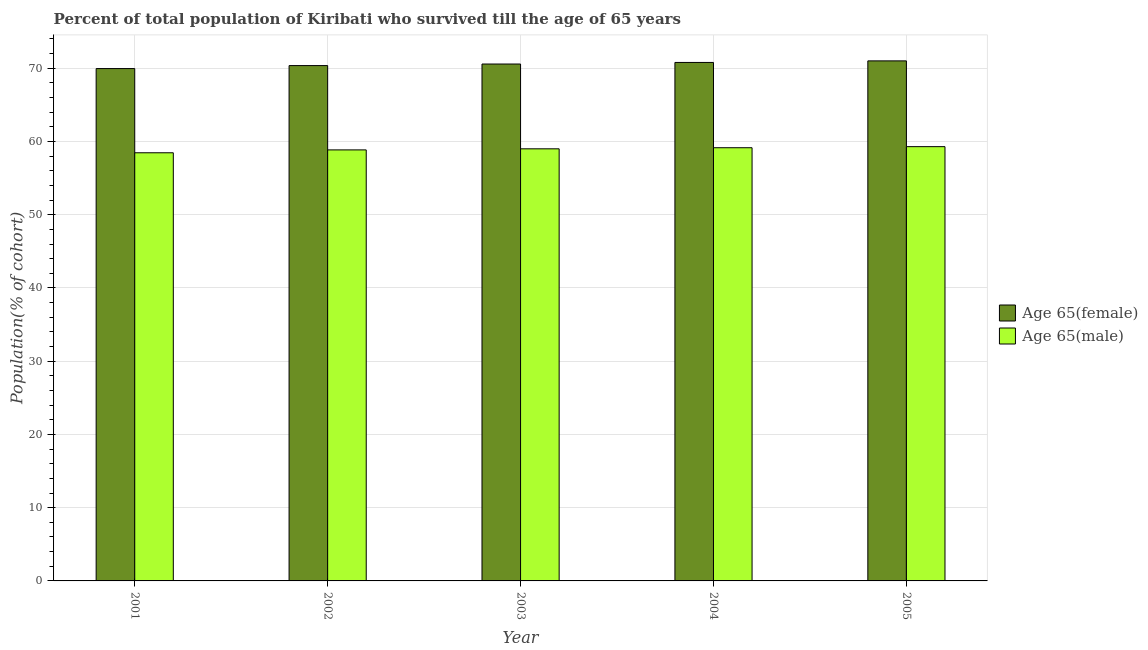Are the number of bars per tick equal to the number of legend labels?
Keep it short and to the point. Yes. Are the number of bars on each tick of the X-axis equal?
Offer a terse response. Yes. How many bars are there on the 1st tick from the right?
Your response must be concise. 2. What is the label of the 1st group of bars from the left?
Ensure brevity in your answer.  2001. In how many cases, is the number of bars for a given year not equal to the number of legend labels?
Offer a very short reply. 0. What is the percentage of male population who survived till age of 65 in 2001?
Your response must be concise. 58.46. Across all years, what is the maximum percentage of male population who survived till age of 65?
Your answer should be very brief. 59.3. Across all years, what is the minimum percentage of female population who survived till age of 65?
Offer a very short reply. 69.96. What is the total percentage of male population who survived till age of 65 in the graph?
Provide a short and direct response. 294.76. What is the difference between the percentage of female population who survived till age of 65 in 2004 and that in 2005?
Give a very brief answer. -0.21. What is the difference between the percentage of male population who survived till age of 65 in 2001 and the percentage of female population who survived till age of 65 in 2004?
Give a very brief answer. -0.69. What is the average percentage of female population who survived till age of 65 per year?
Provide a short and direct response. 70.54. In how many years, is the percentage of male population who survived till age of 65 greater than 42 %?
Keep it short and to the point. 5. What is the ratio of the percentage of male population who survived till age of 65 in 2002 to that in 2004?
Your answer should be very brief. 1. What is the difference between the highest and the second highest percentage of female population who survived till age of 65?
Keep it short and to the point. 0.21. What is the difference between the highest and the lowest percentage of male population who survived till age of 65?
Ensure brevity in your answer.  0.84. What does the 1st bar from the left in 2003 represents?
Your response must be concise. Age 65(female). What does the 1st bar from the right in 2001 represents?
Offer a terse response. Age 65(male). Are all the bars in the graph horizontal?
Your answer should be very brief. No. How many years are there in the graph?
Your response must be concise. 5. What is the difference between two consecutive major ticks on the Y-axis?
Your response must be concise. 10. Does the graph contain grids?
Your answer should be very brief. Yes. Where does the legend appear in the graph?
Make the answer very short. Center right. How are the legend labels stacked?
Provide a succinct answer. Vertical. What is the title of the graph?
Your answer should be very brief. Percent of total population of Kiribati who survived till the age of 65 years. What is the label or title of the Y-axis?
Ensure brevity in your answer.  Population(% of cohort). What is the Population(% of cohort) in Age 65(female) in 2001?
Provide a succinct answer. 69.96. What is the Population(% of cohort) in Age 65(male) in 2001?
Keep it short and to the point. 58.46. What is the Population(% of cohort) in Age 65(female) in 2002?
Your answer should be very brief. 70.37. What is the Population(% of cohort) of Age 65(male) in 2002?
Ensure brevity in your answer.  58.85. What is the Population(% of cohort) of Age 65(female) in 2003?
Your answer should be compact. 70.58. What is the Population(% of cohort) in Age 65(male) in 2003?
Give a very brief answer. 59. What is the Population(% of cohort) of Age 65(female) in 2004?
Give a very brief answer. 70.79. What is the Population(% of cohort) in Age 65(male) in 2004?
Make the answer very short. 59.15. What is the Population(% of cohort) in Age 65(female) in 2005?
Offer a very short reply. 71.01. What is the Population(% of cohort) in Age 65(male) in 2005?
Your answer should be compact. 59.3. Across all years, what is the maximum Population(% of cohort) of Age 65(female)?
Provide a short and direct response. 71.01. Across all years, what is the maximum Population(% of cohort) in Age 65(male)?
Offer a terse response. 59.3. Across all years, what is the minimum Population(% of cohort) in Age 65(female)?
Your response must be concise. 69.96. Across all years, what is the minimum Population(% of cohort) in Age 65(male)?
Make the answer very short. 58.46. What is the total Population(% of cohort) in Age 65(female) in the graph?
Make the answer very short. 352.71. What is the total Population(% of cohort) in Age 65(male) in the graph?
Your answer should be compact. 294.76. What is the difference between the Population(% of cohort) of Age 65(female) in 2001 and that in 2002?
Your answer should be compact. -0.41. What is the difference between the Population(% of cohort) in Age 65(male) in 2001 and that in 2002?
Make the answer very short. -0.39. What is the difference between the Population(% of cohort) in Age 65(female) in 2001 and that in 2003?
Make the answer very short. -0.62. What is the difference between the Population(% of cohort) in Age 65(male) in 2001 and that in 2003?
Make the answer very short. -0.54. What is the difference between the Population(% of cohort) in Age 65(female) in 2001 and that in 2004?
Offer a very short reply. -0.84. What is the difference between the Population(% of cohort) of Age 65(male) in 2001 and that in 2004?
Your response must be concise. -0.69. What is the difference between the Population(% of cohort) of Age 65(female) in 2001 and that in 2005?
Offer a terse response. -1.05. What is the difference between the Population(% of cohort) in Age 65(male) in 2001 and that in 2005?
Ensure brevity in your answer.  -0.84. What is the difference between the Population(% of cohort) in Age 65(female) in 2002 and that in 2003?
Offer a terse response. -0.21. What is the difference between the Population(% of cohort) in Age 65(male) in 2002 and that in 2003?
Provide a short and direct response. -0.15. What is the difference between the Population(% of cohort) in Age 65(female) in 2002 and that in 2004?
Your answer should be very brief. -0.43. What is the difference between the Population(% of cohort) of Age 65(male) in 2002 and that in 2004?
Make the answer very short. -0.3. What is the difference between the Population(% of cohort) of Age 65(female) in 2002 and that in 2005?
Give a very brief answer. -0.64. What is the difference between the Population(% of cohort) of Age 65(male) in 2002 and that in 2005?
Keep it short and to the point. -0.44. What is the difference between the Population(% of cohort) in Age 65(female) in 2003 and that in 2004?
Provide a short and direct response. -0.21. What is the difference between the Population(% of cohort) of Age 65(male) in 2003 and that in 2004?
Your answer should be compact. -0.15. What is the difference between the Population(% of cohort) of Age 65(female) in 2003 and that in 2005?
Give a very brief answer. -0.43. What is the difference between the Population(% of cohort) of Age 65(male) in 2003 and that in 2005?
Offer a terse response. -0.3. What is the difference between the Population(% of cohort) in Age 65(female) in 2004 and that in 2005?
Offer a terse response. -0.21. What is the difference between the Population(% of cohort) in Age 65(male) in 2004 and that in 2005?
Provide a short and direct response. -0.15. What is the difference between the Population(% of cohort) in Age 65(female) in 2001 and the Population(% of cohort) in Age 65(male) in 2002?
Keep it short and to the point. 11.1. What is the difference between the Population(% of cohort) of Age 65(female) in 2001 and the Population(% of cohort) of Age 65(male) in 2003?
Offer a very short reply. 10.96. What is the difference between the Population(% of cohort) in Age 65(female) in 2001 and the Population(% of cohort) in Age 65(male) in 2004?
Provide a succinct answer. 10.81. What is the difference between the Population(% of cohort) in Age 65(female) in 2001 and the Population(% of cohort) in Age 65(male) in 2005?
Keep it short and to the point. 10.66. What is the difference between the Population(% of cohort) in Age 65(female) in 2002 and the Population(% of cohort) in Age 65(male) in 2003?
Your answer should be very brief. 11.36. What is the difference between the Population(% of cohort) of Age 65(female) in 2002 and the Population(% of cohort) of Age 65(male) in 2004?
Provide a succinct answer. 11.22. What is the difference between the Population(% of cohort) of Age 65(female) in 2002 and the Population(% of cohort) of Age 65(male) in 2005?
Keep it short and to the point. 11.07. What is the difference between the Population(% of cohort) of Age 65(female) in 2003 and the Population(% of cohort) of Age 65(male) in 2004?
Make the answer very short. 11.43. What is the difference between the Population(% of cohort) of Age 65(female) in 2003 and the Population(% of cohort) of Age 65(male) in 2005?
Your response must be concise. 11.28. What is the difference between the Population(% of cohort) in Age 65(female) in 2004 and the Population(% of cohort) in Age 65(male) in 2005?
Your answer should be compact. 11.5. What is the average Population(% of cohort) of Age 65(female) per year?
Make the answer very short. 70.54. What is the average Population(% of cohort) in Age 65(male) per year?
Your answer should be compact. 58.95. In the year 2001, what is the difference between the Population(% of cohort) in Age 65(female) and Population(% of cohort) in Age 65(male)?
Ensure brevity in your answer.  11.5. In the year 2002, what is the difference between the Population(% of cohort) in Age 65(female) and Population(% of cohort) in Age 65(male)?
Offer a terse response. 11.51. In the year 2003, what is the difference between the Population(% of cohort) of Age 65(female) and Population(% of cohort) of Age 65(male)?
Your answer should be very brief. 11.58. In the year 2004, what is the difference between the Population(% of cohort) in Age 65(female) and Population(% of cohort) in Age 65(male)?
Offer a very short reply. 11.65. In the year 2005, what is the difference between the Population(% of cohort) of Age 65(female) and Population(% of cohort) of Age 65(male)?
Provide a succinct answer. 11.71. What is the ratio of the Population(% of cohort) in Age 65(female) in 2001 to that in 2003?
Provide a short and direct response. 0.99. What is the ratio of the Population(% of cohort) in Age 65(male) in 2001 to that in 2004?
Ensure brevity in your answer.  0.99. What is the ratio of the Population(% of cohort) of Age 65(female) in 2001 to that in 2005?
Provide a succinct answer. 0.99. What is the ratio of the Population(% of cohort) of Age 65(male) in 2001 to that in 2005?
Your answer should be very brief. 0.99. What is the ratio of the Population(% of cohort) in Age 65(female) in 2002 to that in 2003?
Make the answer very short. 1. What is the ratio of the Population(% of cohort) of Age 65(female) in 2002 to that in 2004?
Offer a very short reply. 0.99. What is the ratio of the Population(% of cohort) in Age 65(male) in 2002 to that in 2004?
Make the answer very short. 0.99. What is the ratio of the Population(% of cohort) of Age 65(female) in 2002 to that in 2005?
Provide a succinct answer. 0.99. What is the ratio of the Population(% of cohort) in Age 65(female) in 2003 to that in 2005?
Ensure brevity in your answer.  0.99. What is the difference between the highest and the second highest Population(% of cohort) of Age 65(female)?
Ensure brevity in your answer.  0.21. What is the difference between the highest and the second highest Population(% of cohort) in Age 65(male)?
Your response must be concise. 0.15. What is the difference between the highest and the lowest Population(% of cohort) in Age 65(female)?
Provide a succinct answer. 1.05. What is the difference between the highest and the lowest Population(% of cohort) in Age 65(male)?
Provide a short and direct response. 0.84. 